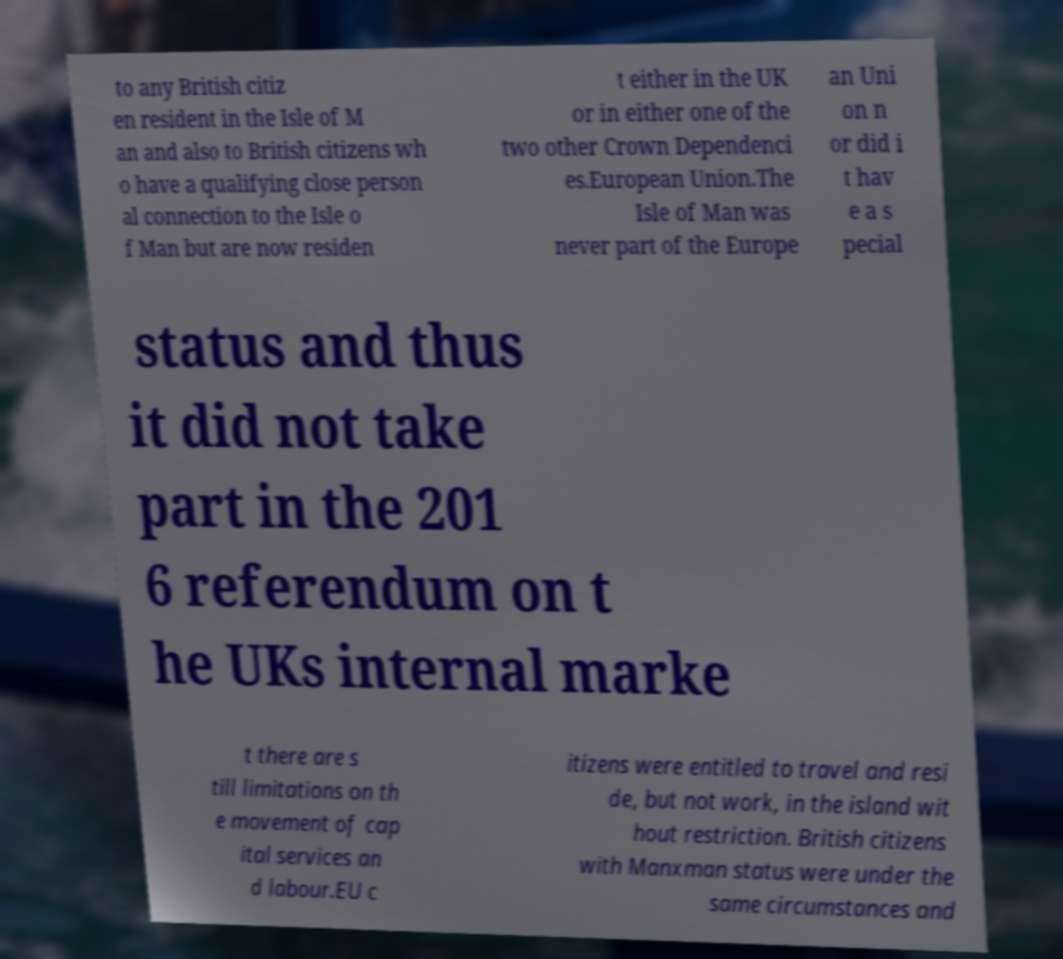Could you extract and type out the text from this image? to any British citiz en resident in the Isle of M an and also to British citizens wh o have a qualifying close person al connection to the Isle o f Man but are now residen t either in the UK or in either one of the two other Crown Dependenci es.European Union.The Isle of Man was never part of the Europe an Uni on n or did i t hav e a s pecial status and thus it did not take part in the 201 6 referendum on t he UKs internal marke t there are s till limitations on th e movement of cap ital services an d labour.EU c itizens were entitled to travel and resi de, but not work, in the island wit hout restriction. British citizens with Manxman status were under the same circumstances and 